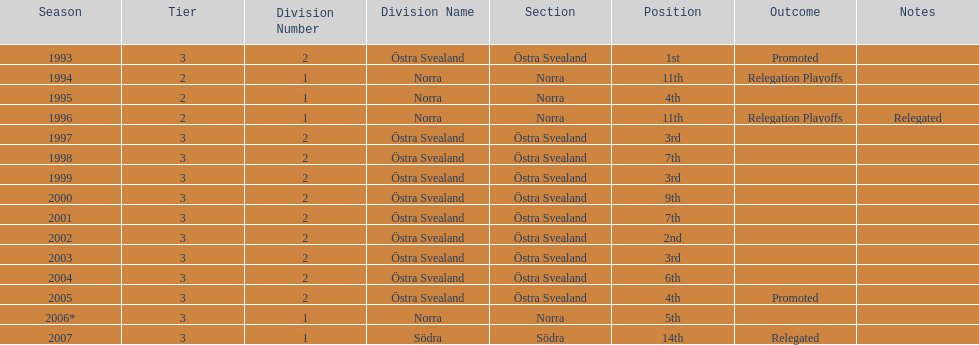They placed third in 2003. when did they place third before that? 1999. 